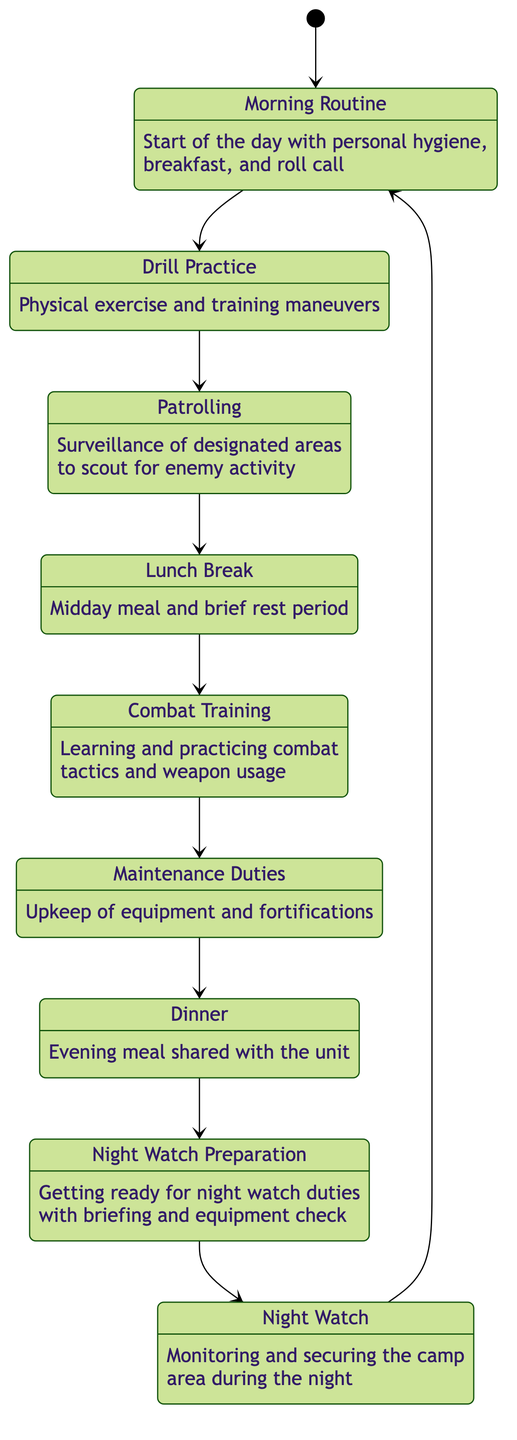What is the first state in the diagram? The first state in the diagram, indicated by [*], leads to Morning Routine, which begins the sequence for the daily routine of the soldier.
Answer: Morning Routine How many states are there in total? By counting each listed state in the diagram, there are a total of nine states that describe the daily routine.
Answer: 9 What comes directly after Combat Training? Examining the transitions, the next state that follows Combat Training is Maintenance Duties, as indicated by a direct connection.
Answer: Maintenance Duties What is the last state before returning to the first state? The last state before cycling back to the initial state of Morning Routine is Night Watch, which signifies the end of the daily cycle.
Answer: Night Watch Which state involves physical exercise? Reflecting on the descriptions of the states, Drill Practice is the specific state that emphasizes physical exercise and training maneuvers.
Answer: Drill Practice What activities are included in the Lunch Break? While the diagram does not extend into very specific details about Lunch Break, it indicates that it involves a midday meal and a brief rest period.
Answer: Midday meal and brief rest period How many transitions occur from the Dinner state? Upon reviewing the transitions from the Dinner state, there is one direct transition that leads to Night Watch Preparation, thus indicating a single transition.
Answer: 1 Which two states are connected by a transition involving equipment management? By looking closely at the transitions, the states of Combat Training and Maintenance Duties are connected by the practice of equipment management, representing the upkeep necessary for training.
Answer: Combat Training and Maintenance Duties What is the common function of the Patrolling state? The description clearly states that Patrolling involves surveillance of designated areas to scout for enemy activity, showcasing its key function in the soldier's routine.
Answer: Surveillance of designated areas to scout for enemy activity 